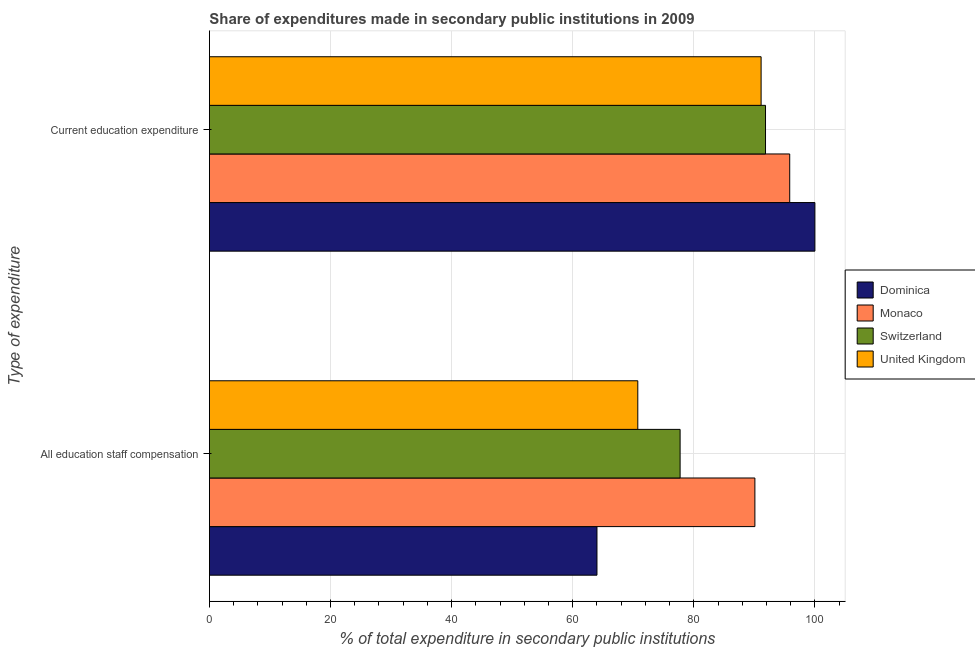How many different coloured bars are there?
Make the answer very short. 4. How many groups of bars are there?
Offer a very short reply. 2. Are the number of bars on each tick of the Y-axis equal?
Give a very brief answer. Yes. How many bars are there on the 1st tick from the top?
Ensure brevity in your answer.  4. What is the label of the 1st group of bars from the top?
Your response must be concise. Current education expenditure. What is the expenditure in staff compensation in Switzerland?
Your answer should be very brief. 77.74. Across all countries, what is the maximum expenditure in staff compensation?
Provide a succinct answer. 90.09. Across all countries, what is the minimum expenditure in education?
Your answer should be compact. 91.11. In which country was the expenditure in staff compensation maximum?
Offer a very short reply. Monaco. In which country was the expenditure in staff compensation minimum?
Provide a succinct answer. Dominica. What is the total expenditure in education in the graph?
Provide a succinct answer. 378.8. What is the difference between the expenditure in education in United Kingdom and that in Monaco?
Your response must be concise. -4.73. What is the difference between the expenditure in staff compensation in Switzerland and the expenditure in education in Monaco?
Ensure brevity in your answer.  -18.1. What is the average expenditure in staff compensation per country?
Provide a short and direct response. 75.65. What is the difference between the expenditure in staff compensation and expenditure in education in Switzerland?
Provide a short and direct response. -14.11. In how many countries, is the expenditure in education greater than 16 %?
Keep it short and to the point. 4. What is the ratio of the expenditure in staff compensation in Dominica to that in Monaco?
Provide a short and direct response. 0.71. What does the 3rd bar from the bottom in Current education expenditure represents?
Make the answer very short. Switzerland. What is the difference between two consecutive major ticks on the X-axis?
Offer a very short reply. 20. Are the values on the major ticks of X-axis written in scientific E-notation?
Provide a succinct answer. No. Where does the legend appear in the graph?
Provide a succinct answer. Center right. What is the title of the graph?
Make the answer very short. Share of expenditures made in secondary public institutions in 2009. Does "Sub-Saharan Africa (all income levels)" appear as one of the legend labels in the graph?
Your answer should be very brief. No. What is the label or title of the X-axis?
Keep it short and to the point. % of total expenditure in secondary public institutions. What is the label or title of the Y-axis?
Your response must be concise. Type of expenditure. What is the % of total expenditure in secondary public institutions of Dominica in All education staff compensation?
Give a very brief answer. 64.01. What is the % of total expenditure in secondary public institutions of Monaco in All education staff compensation?
Offer a very short reply. 90.09. What is the % of total expenditure in secondary public institutions in Switzerland in All education staff compensation?
Ensure brevity in your answer.  77.74. What is the % of total expenditure in secondary public institutions of United Kingdom in All education staff compensation?
Give a very brief answer. 70.75. What is the % of total expenditure in secondary public institutions in Dominica in Current education expenditure?
Offer a very short reply. 100. What is the % of total expenditure in secondary public institutions of Monaco in Current education expenditure?
Your answer should be compact. 95.84. What is the % of total expenditure in secondary public institutions of Switzerland in Current education expenditure?
Offer a terse response. 91.84. What is the % of total expenditure in secondary public institutions of United Kingdom in Current education expenditure?
Your response must be concise. 91.11. Across all Type of expenditure, what is the maximum % of total expenditure in secondary public institutions in Dominica?
Ensure brevity in your answer.  100. Across all Type of expenditure, what is the maximum % of total expenditure in secondary public institutions in Monaco?
Keep it short and to the point. 95.84. Across all Type of expenditure, what is the maximum % of total expenditure in secondary public institutions of Switzerland?
Offer a very short reply. 91.84. Across all Type of expenditure, what is the maximum % of total expenditure in secondary public institutions in United Kingdom?
Provide a short and direct response. 91.11. Across all Type of expenditure, what is the minimum % of total expenditure in secondary public institutions in Dominica?
Your answer should be compact. 64.01. Across all Type of expenditure, what is the minimum % of total expenditure in secondary public institutions in Monaco?
Provide a succinct answer. 90.09. Across all Type of expenditure, what is the minimum % of total expenditure in secondary public institutions in Switzerland?
Ensure brevity in your answer.  77.74. Across all Type of expenditure, what is the minimum % of total expenditure in secondary public institutions of United Kingdom?
Give a very brief answer. 70.75. What is the total % of total expenditure in secondary public institutions of Dominica in the graph?
Make the answer very short. 164.01. What is the total % of total expenditure in secondary public institutions of Monaco in the graph?
Your answer should be very brief. 185.93. What is the total % of total expenditure in secondary public institutions of Switzerland in the graph?
Your answer should be compact. 169.58. What is the total % of total expenditure in secondary public institutions of United Kingdom in the graph?
Keep it short and to the point. 161.86. What is the difference between the % of total expenditure in secondary public institutions of Dominica in All education staff compensation and that in Current education expenditure?
Ensure brevity in your answer.  -35.99. What is the difference between the % of total expenditure in secondary public institutions in Monaco in All education staff compensation and that in Current education expenditure?
Your answer should be very brief. -5.75. What is the difference between the % of total expenditure in secondary public institutions in Switzerland in All education staff compensation and that in Current education expenditure?
Offer a terse response. -14.11. What is the difference between the % of total expenditure in secondary public institutions of United Kingdom in All education staff compensation and that in Current education expenditure?
Provide a succinct answer. -20.37. What is the difference between the % of total expenditure in secondary public institutions of Dominica in All education staff compensation and the % of total expenditure in secondary public institutions of Monaco in Current education expenditure?
Your answer should be compact. -31.83. What is the difference between the % of total expenditure in secondary public institutions of Dominica in All education staff compensation and the % of total expenditure in secondary public institutions of Switzerland in Current education expenditure?
Keep it short and to the point. -27.84. What is the difference between the % of total expenditure in secondary public institutions of Dominica in All education staff compensation and the % of total expenditure in secondary public institutions of United Kingdom in Current education expenditure?
Your response must be concise. -27.11. What is the difference between the % of total expenditure in secondary public institutions in Monaco in All education staff compensation and the % of total expenditure in secondary public institutions in Switzerland in Current education expenditure?
Make the answer very short. -1.75. What is the difference between the % of total expenditure in secondary public institutions of Monaco in All education staff compensation and the % of total expenditure in secondary public institutions of United Kingdom in Current education expenditure?
Make the answer very short. -1.03. What is the difference between the % of total expenditure in secondary public institutions in Switzerland in All education staff compensation and the % of total expenditure in secondary public institutions in United Kingdom in Current education expenditure?
Offer a very short reply. -13.38. What is the average % of total expenditure in secondary public institutions in Dominica per Type of expenditure?
Offer a terse response. 82. What is the average % of total expenditure in secondary public institutions in Monaco per Type of expenditure?
Ensure brevity in your answer.  92.97. What is the average % of total expenditure in secondary public institutions of Switzerland per Type of expenditure?
Offer a terse response. 84.79. What is the average % of total expenditure in secondary public institutions in United Kingdom per Type of expenditure?
Your answer should be very brief. 80.93. What is the difference between the % of total expenditure in secondary public institutions in Dominica and % of total expenditure in secondary public institutions in Monaco in All education staff compensation?
Make the answer very short. -26.08. What is the difference between the % of total expenditure in secondary public institutions in Dominica and % of total expenditure in secondary public institutions in Switzerland in All education staff compensation?
Your answer should be compact. -13.73. What is the difference between the % of total expenditure in secondary public institutions of Dominica and % of total expenditure in secondary public institutions of United Kingdom in All education staff compensation?
Your response must be concise. -6.74. What is the difference between the % of total expenditure in secondary public institutions of Monaco and % of total expenditure in secondary public institutions of Switzerland in All education staff compensation?
Provide a succinct answer. 12.35. What is the difference between the % of total expenditure in secondary public institutions of Monaco and % of total expenditure in secondary public institutions of United Kingdom in All education staff compensation?
Provide a succinct answer. 19.34. What is the difference between the % of total expenditure in secondary public institutions in Switzerland and % of total expenditure in secondary public institutions in United Kingdom in All education staff compensation?
Provide a succinct answer. 6.99. What is the difference between the % of total expenditure in secondary public institutions in Dominica and % of total expenditure in secondary public institutions in Monaco in Current education expenditure?
Your answer should be very brief. 4.16. What is the difference between the % of total expenditure in secondary public institutions of Dominica and % of total expenditure in secondary public institutions of Switzerland in Current education expenditure?
Provide a succinct answer. 8.16. What is the difference between the % of total expenditure in secondary public institutions in Dominica and % of total expenditure in secondary public institutions in United Kingdom in Current education expenditure?
Keep it short and to the point. 8.88. What is the difference between the % of total expenditure in secondary public institutions in Monaco and % of total expenditure in secondary public institutions in Switzerland in Current education expenditure?
Provide a short and direct response. 4. What is the difference between the % of total expenditure in secondary public institutions of Monaco and % of total expenditure in secondary public institutions of United Kingdom in Current education expenditure?
Your response must be concise. 4.73. What is the difference between the % of total expenditure in secondary public institutions of Switzerland and % of total expenditure in secondary public institutions of United Kingdom in Current education expenditure?
Offer a very short reply. 0.73. What is the ratio of the % of total expenditure in secondary public institutions of Dominica in All education staff compensation to that in Current education expenditure?
Your answer should be compact. 0.64. What is the ratio of the % of total expenditure in secondary public institutions of Switzerland in All education staff compensation to that in Current education expenditure?
Ensure brevity in your answer.  0.85. What is the ratio of the % of total expenditure in secondary public institutions of United Kingdom in All education staff compensation to that in Current education expenditure?
Your answer should be very brief. 0.78. What is the difference between the highest and the second highest % of total expenditure in secondary public institutions in Dominica?
Ensure brevity in your answer.  35.99. What is the difference between the highest and the second highest % of total expenditure in secondary public institutions in Monaco?
Your answer should be very brief. 5.75. What is the difference between the highest and the second highest % of total expenditure in secondary public institutions of Switzerland?
Your response must be concise. 14.11. What is the difference between the highest and the second highest % of total expenditure in secondary public institutions of United Kingdom?
Your response must be concise. 20.37. What is the difference between the highest and the lowest % of total expenditure in secondary public institutions in Dominica?
Offer a very short reply. 35.99. What is the difference between the highest and the lowest % of total expenditure in secondary public institutions of Monaco?
Ensure brevity in your answer.  5.75. What is the difference between the highest and the lowest % of total expenditure in secondary public institutions of Switzerland?
Give a very brief answer. 14.11. What is the difference between the highest and the lowest % of total expenditure in secondary public institutions in United Kingdom?
Keep it short and to the point. 20.37. 